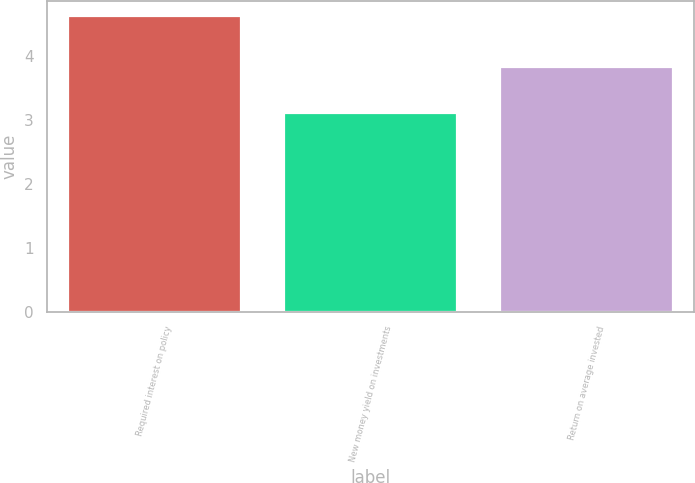Convert chart to OTSL. <chart><loc_0><loc_0><loc_500><loc_500><bar_chart><fcel>Required interest on policy<fcel>New money yield on investments<fcel>Return on average invested<nl><fcel>4.63<fcel>3.11<fcel>3.83<nl></chart> 